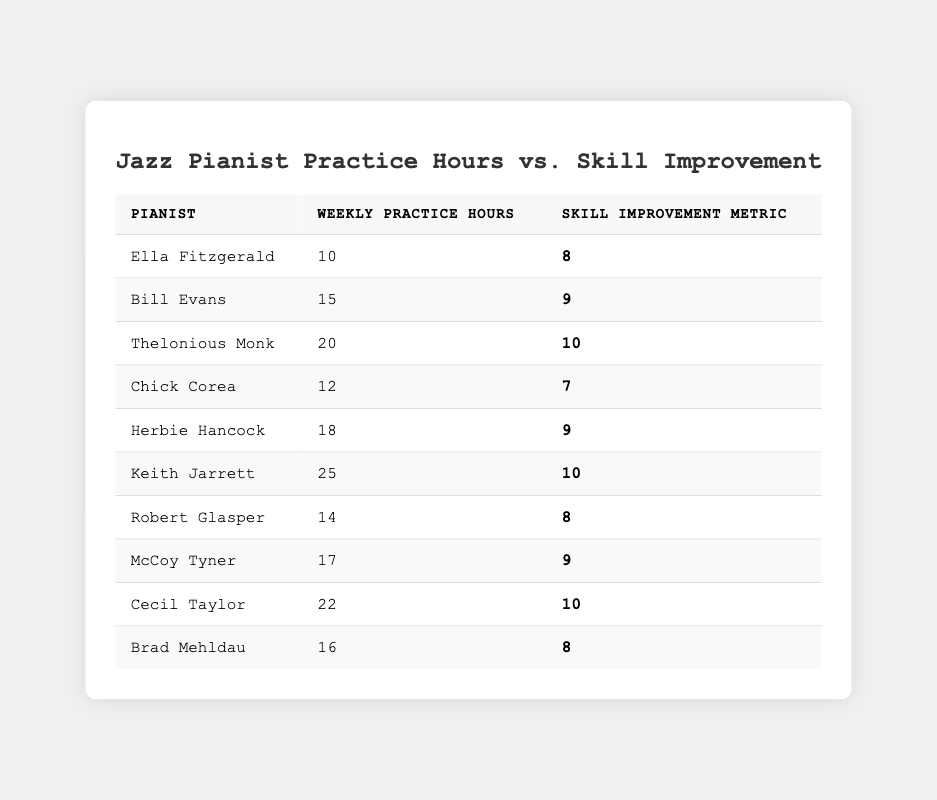What is the highest skill improvement metric recorded? The skill improvement metrics are listed as 8, 9, and 10. The highest value among them is 10.
Answer: 10 Who practiced for the least number of hours? The pianists with the least hours are Ella Fitzgerald with 10 hours and Chick Corea with 12 hours. Ella Fitzgerald practiced the least.
Answer: Ella Fitzgerald How many pianists practiced for more than 15 hours? The pianists who practiced for more than 15 hours are Thelonious Monk (20), Herbie Hancock (18), Keith Jarrett (25), Cecil Taylor (22), and McCoy Tyner (17), which adds up to 5 pianists.
Answer: 5 What is the total number of weekly practice hours among all the pianists? By adding all practice hours: 10 + 15 + 20 + 12 + 18 + 25 + 14 + 17 + 22 + 16 =  180.
Answer: 180 Which pianist had a skill improvement metric of 7? The skill improvement metrics show that Chick Corea has a skill improvement metric of 7.
Answer: Chick Corea Is there any pianist who practiced for 22 hours? Yes, Cecil Taylor practiced for 22 hours, as seen in the table.
Answer: Yes What is the average skill improvement metric for all pianists? To find the average, add all the skill improvement metrics: 8 + 9 + 10 + 7 + 9 + 10 + 8 + 9 + 10 + 8 = 88. There are 10 pianists, so the average is 88 / 10 = 8.8.
Answer: 8.8 Which pianist had the same skill improvement metric as Robert Glasper? Robert Glasper has a skill improvement metric of 8. The pianists who also have this metric are Ella Fitzgerald and Brad Mehldau, both of whom also recorded an 8.
Answer: Ella Fitzgerald, Brad Mehldau What is the difference in practice hours between Keith Jarrett and Bill Evans? Keith Jarrett practiced for 25 hours, while Bill Evans practiced for 15 hours. The difference is 25 - 15 = 10 hours.
Answer: 10 hours Are more pianists practicing for 20 hours or less than 20 hours? The pianists who practiced for 20 hours or less are Ella Fitzgerald (10), Bill Evans (15), Chick Corea (12), Robert Glasper (14), McCoy Tyner (17), and Brad Mehldau (16) totaling 6 pianists. The ones practicing for more than 20 hours are Thelonious Monk (20), Herbie Hancock (18), Keith Jarrett (25), and Cecil Taylor (22), which totals 4 pianists. Since 6 is greater than 4, the answer is yes.
Answer: Yes 